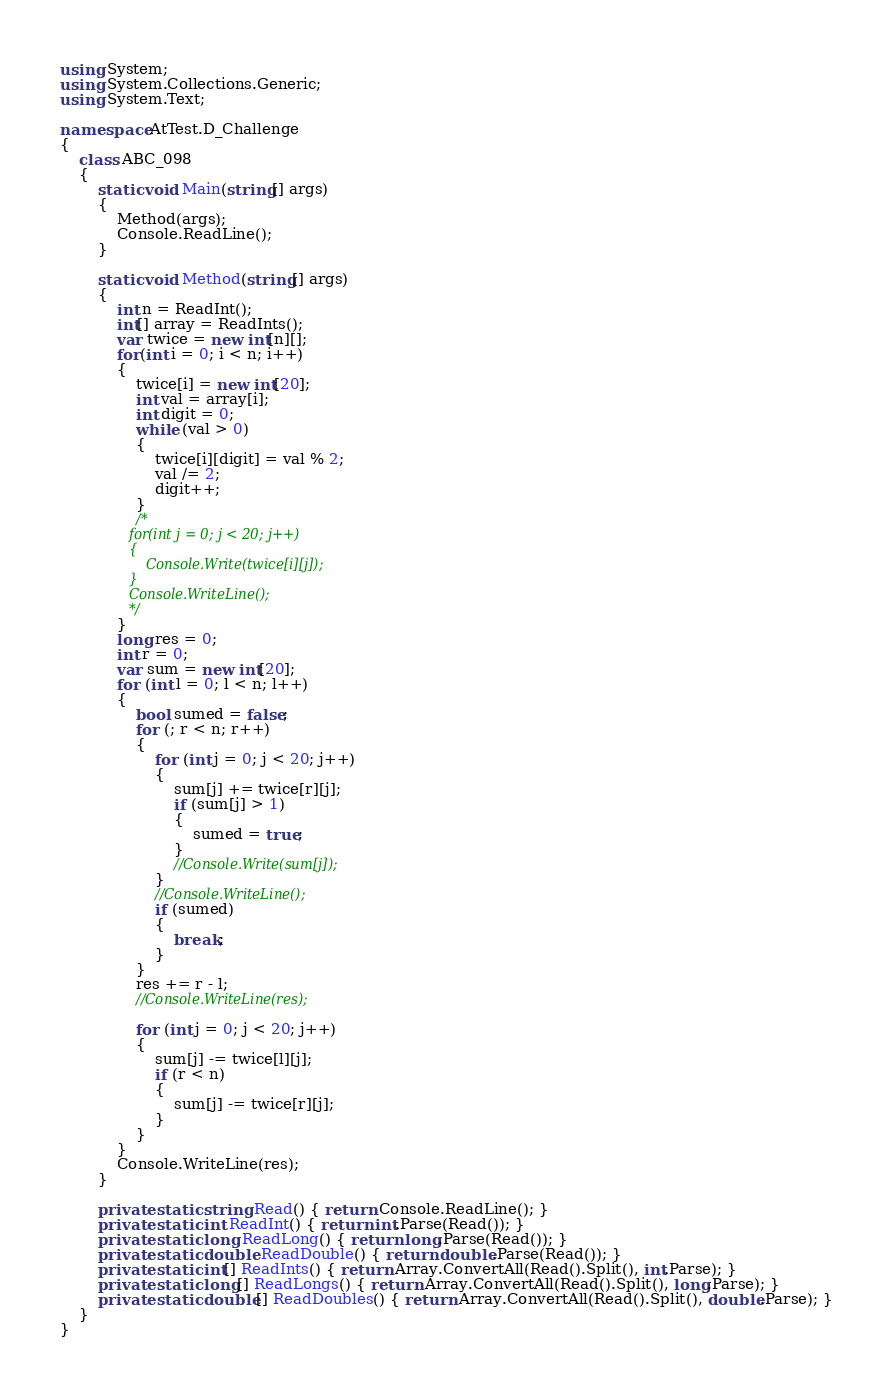<code> <loc_0><loc_0><loc_500><loc_500><_C#_>using System;
using System.Collections.Generic;
using System.Text;

namespace AtTest.D_Challenge
{
    class ABC_098
    {
        static void Main(string[] args)
        {
            Method(args);
            Console.ReadLine();
        }

        static void Method(string[] args)
        {
            int n = ReadInt();
            int[] array = ReadInts();
            var twice = new int[n][];
            for(int i = 0; i < n; i++)
            {
                twice[i] = new int[20];
                int val = array[i];
                int digit = 0;
                while (val > 0)
                {
                    twice[i][digit] = val % 2;
                    val /= 2;
                    digit++;
                }
                /*
                for(int j = 0; j < 20; j++)
                {
                    Console.Write(twice[i][j]);
                }
                Console.WriteLine();
                */
            }
            long res = 0;
            int r = 0;
            var sum = new int[20];
            for (int l = 0; l < n; l++)
            {
                bool sumed = false;
                for (; r < n; r++)
                {
                    for (int j = 0; j < 20; j++)
                    {
                        sum[j] += twice[r][j];
                        if (sum[j] > 1)
                        {
                            sumed = true;
                        }
                        //Console.Write(sum[j]);
                    }
                    //Console.WriteLine();
                    if (sumed)
                    {
                        break;
                    }
                }
                res += r - l;
                //Console.WriteLine(res);

                for (int j = 0; j < 20; j++)
                {
                    sum[j] -= twice[l][j];
                    if (r < n)
                    {
                        sum[j] -= twice[r][j];
                    }
                }
            }
            Console.WriteLine(res);
        }

        private static string Read() { return Console.ReadLine(); }
        private static int ReadInt() { return int.Parse(Read()); }
        private static long ReadLong() { return long.Parse(Read()); }
        private static double ReadDouble() { return double.Parse(Read()); }
        private static int[] ReadInts() { return Array.ConvertAll(Read().Split(), int.Parse); }
        private static long[] ReadLongs() { return Array.ConvertAll(Read().Split(), long.Parse); }
        private static double[] ReadDoubles() { return Array.ConvertAll(Read().Split(), double.Parse); }
    }
}
</code> 